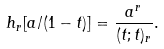Convert formula to latex. <formula><loc_0><loc_0><loc_500><loc_500>h _ { r } [ a / ( 1 - t ) ] = \frac { a ^ { r } } { ( t ; t ) _ { r } } .</formula> 